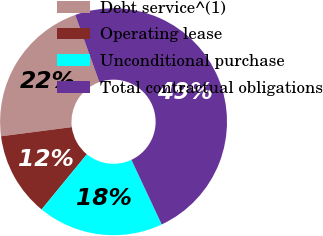Convert chart. <chart><loc_0><loc_0><loc_500><loc_500><pie_chart><fcel>Debt service^(1)<fcel>Operating lease<fcel>Unconditional purchase<fcel>Total contractual obligations<nl><fcel>21.56%<fcel>12.02%<fcel>17.91%<fcel>48.5%<nl></chart> 